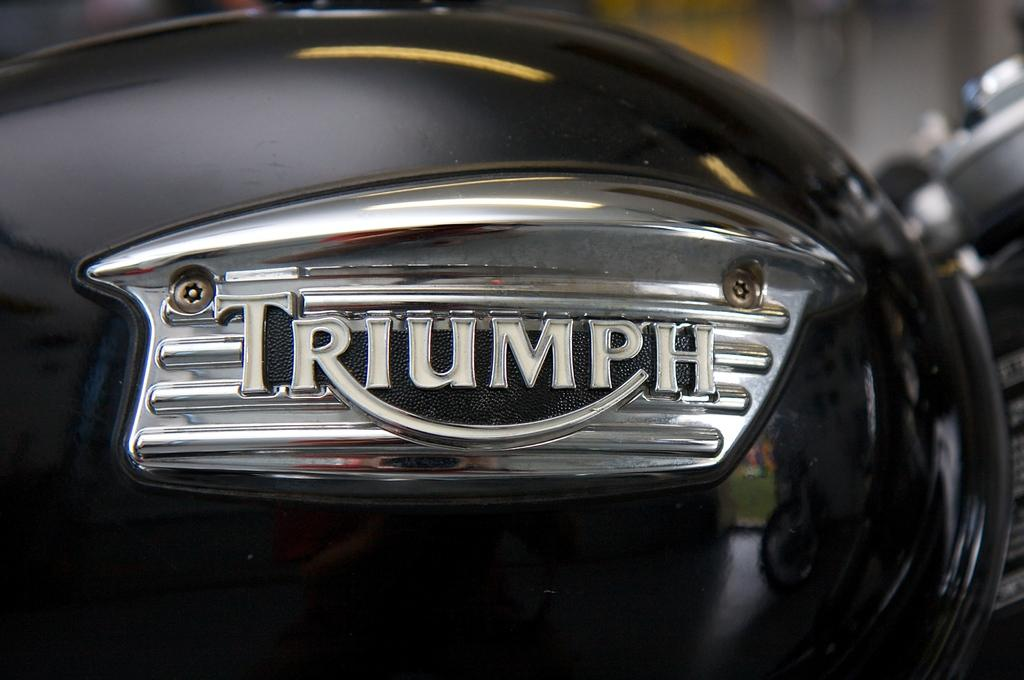What is the main object in the center of the image? There is a helmet in the center of the image. What can be seen on the right side of the image? There are objects on the right side of the image. What is visible at the top of the image? There is a wall visible at the top of the image. What type of meat is being prepared on the island in the image? There is no meat or island present in the image; it only features a helmet and other objects. 